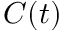Convert formula to latex. <formula><loc_0><loc_0><loc_500><loc_500>C ( t )</formula> 